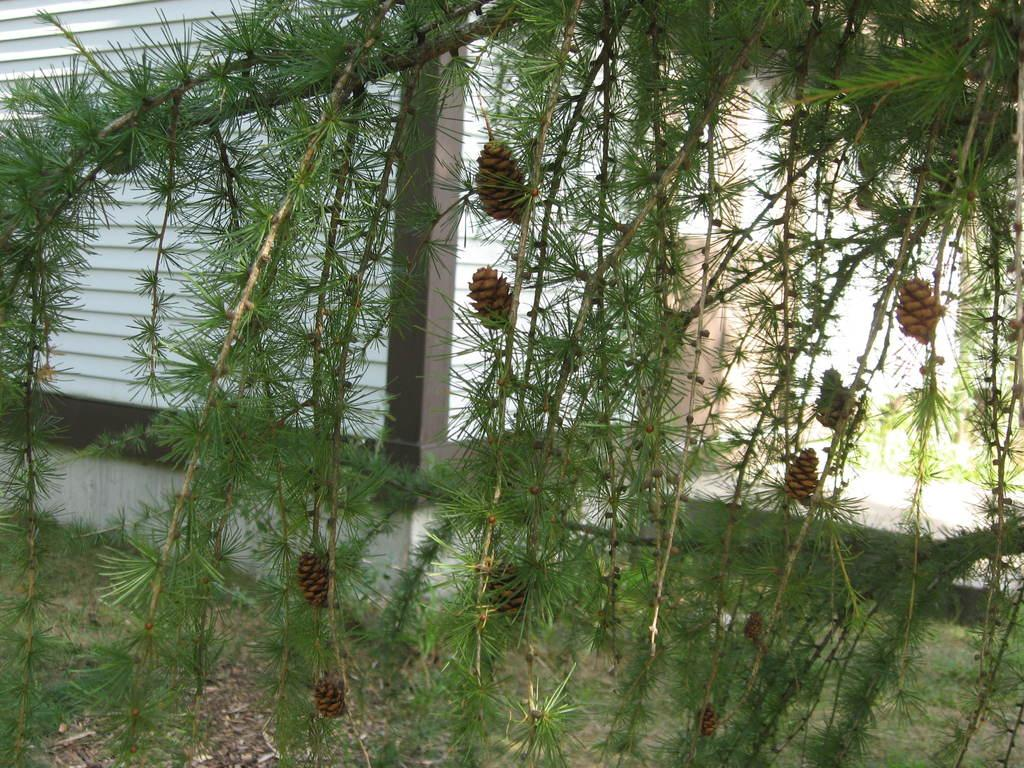What type of plant is depicted in the image? There are leaves on stems in the image, which suggests a plant. What color are the objects on the stems? The objects on the stems are brown in color. What can be seen below the stems in the image? The ground is visible in the image. What is visible behind the plant in the image? There is a white wall in the background of the image. Did the parent give their approval for the dirt in the image? There is no reference to a parent or approval in the image, and the image does not depict dirt. 